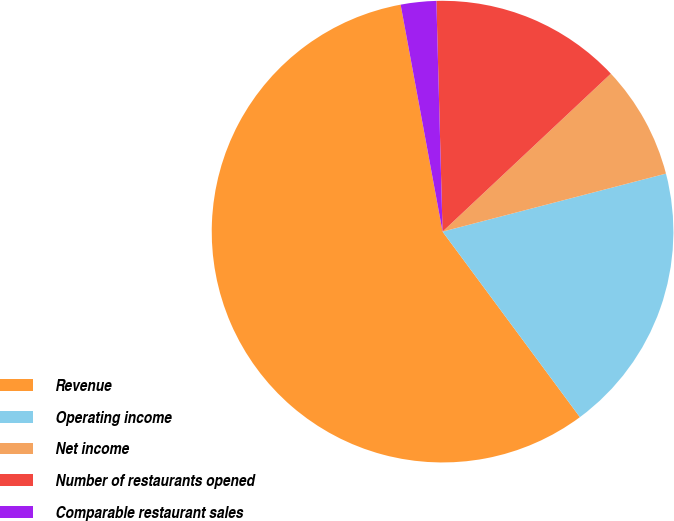<chart> <loc_0><loc_0><loc_500><loc_500><pie_chart><fcel>Revenue<fcel>Operating income<fcel>Net income<fcel>Number of restaurants opened<fcel>Comparable restaurant sales<nl><fcel>57.23%<fcel>18.9%<fcel>7.95%<fcel>13.43%<fcel>2.48%<nl></chart> 